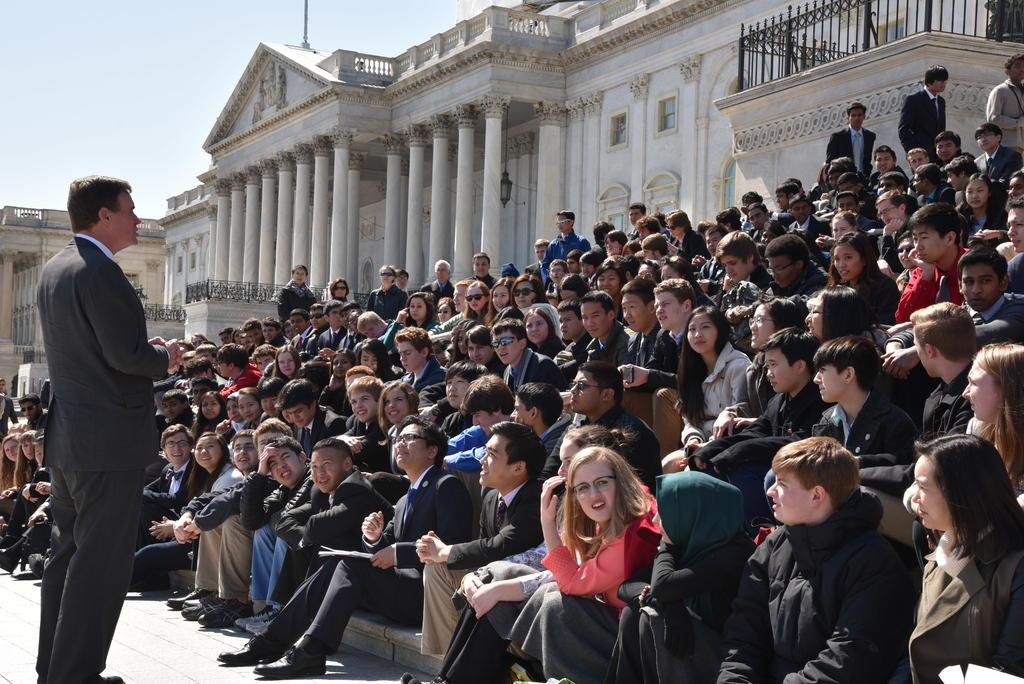What is the main subject of the image? There is a man standing in the image. Where is the man standing? The man is standing on the floor. What is in front of the man? There is a group of people in front of the man. What type of structures can be seen in the image? There are buildings with windows in the image. What else can be seen in the image besides the man and the buildings? There are objects visible in the image. What is visible in the background of the image? The sky is visible in the background of the image. How many jellyfish are swimming in the sky in the image? There are no jellyfish present in the image, and the sky is not a body of water where jellyfish would be found. 